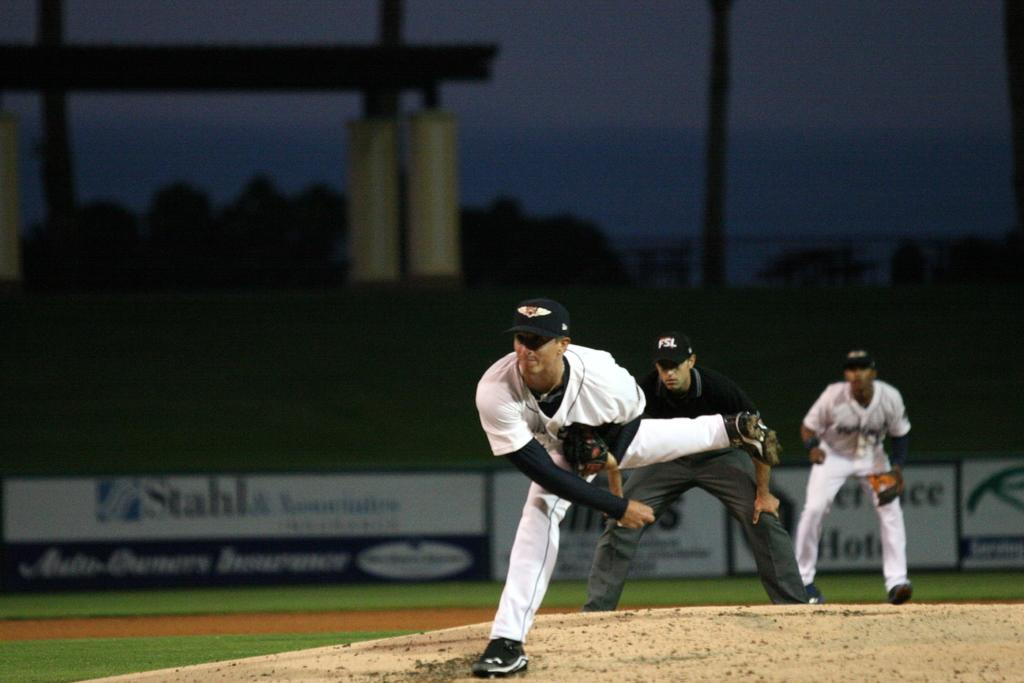<image>
Describe the image concisely. The pitcher is in action on the mound with an advertisement for Stahl in the background. 